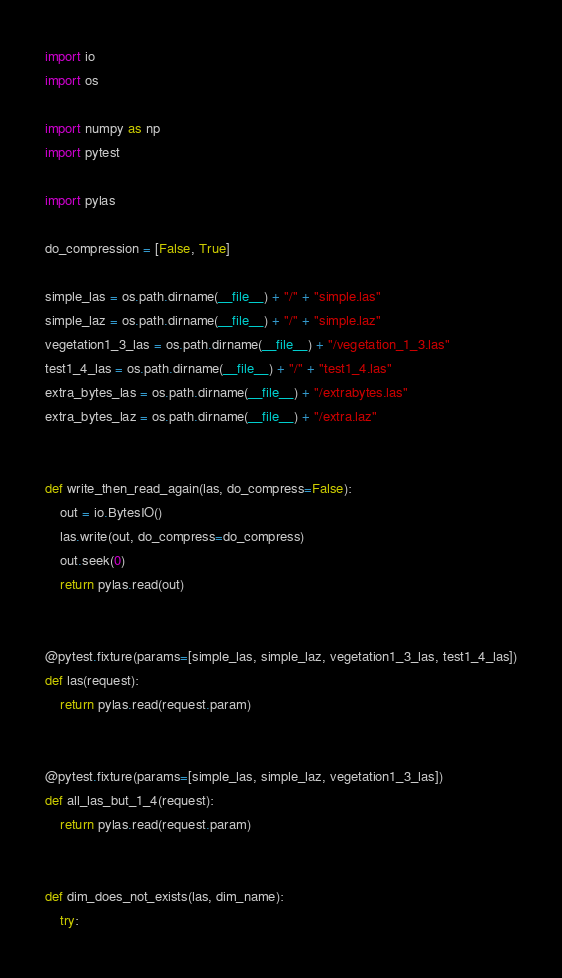<code> <loc_0><loc_0><loc_500><loc_500><_Python_>import io
import os

import numpy as np
import pytest

import pylas

do_compression = [False, True]

simple_las = os.path.dirname(__file__) + "/" + "simple.las"
simple_laz = os.path.dirname(__file__) + "/" + "simple.laz"
vegetation1_3_las = os.path.dirname(__file__) + "/vegetation_1_3.las"
test1_4_las = os.path.dirname(__file__) + "/" + "test1_4.las"
extra_bytes_las = os.path.dirname(__file__) + "/extrabytes.las"
extra_bytes_laz = os.path.dirname(__file__) + "/extra.laz"


def write_then_read_again(las, do_compress=False):
    out = io.BytesIO()
    las.write(out, do_compress=do_compress)
    out.seek(0)
    return pylas.read(out)


@pytest.fixture(params=[simple_las, simple_laz, vegetation1_3_las, test1_4_las])
def las(request):
    return pylas.read(request.param)


@pytest.fixture(params=[simple_las, simple_laz, vegetation1_3_las])
def all_las_but_1_4(request):
    return pylas.read(request.param)


def dim_does_not_exists(las, dim_name):
    try:</code> 